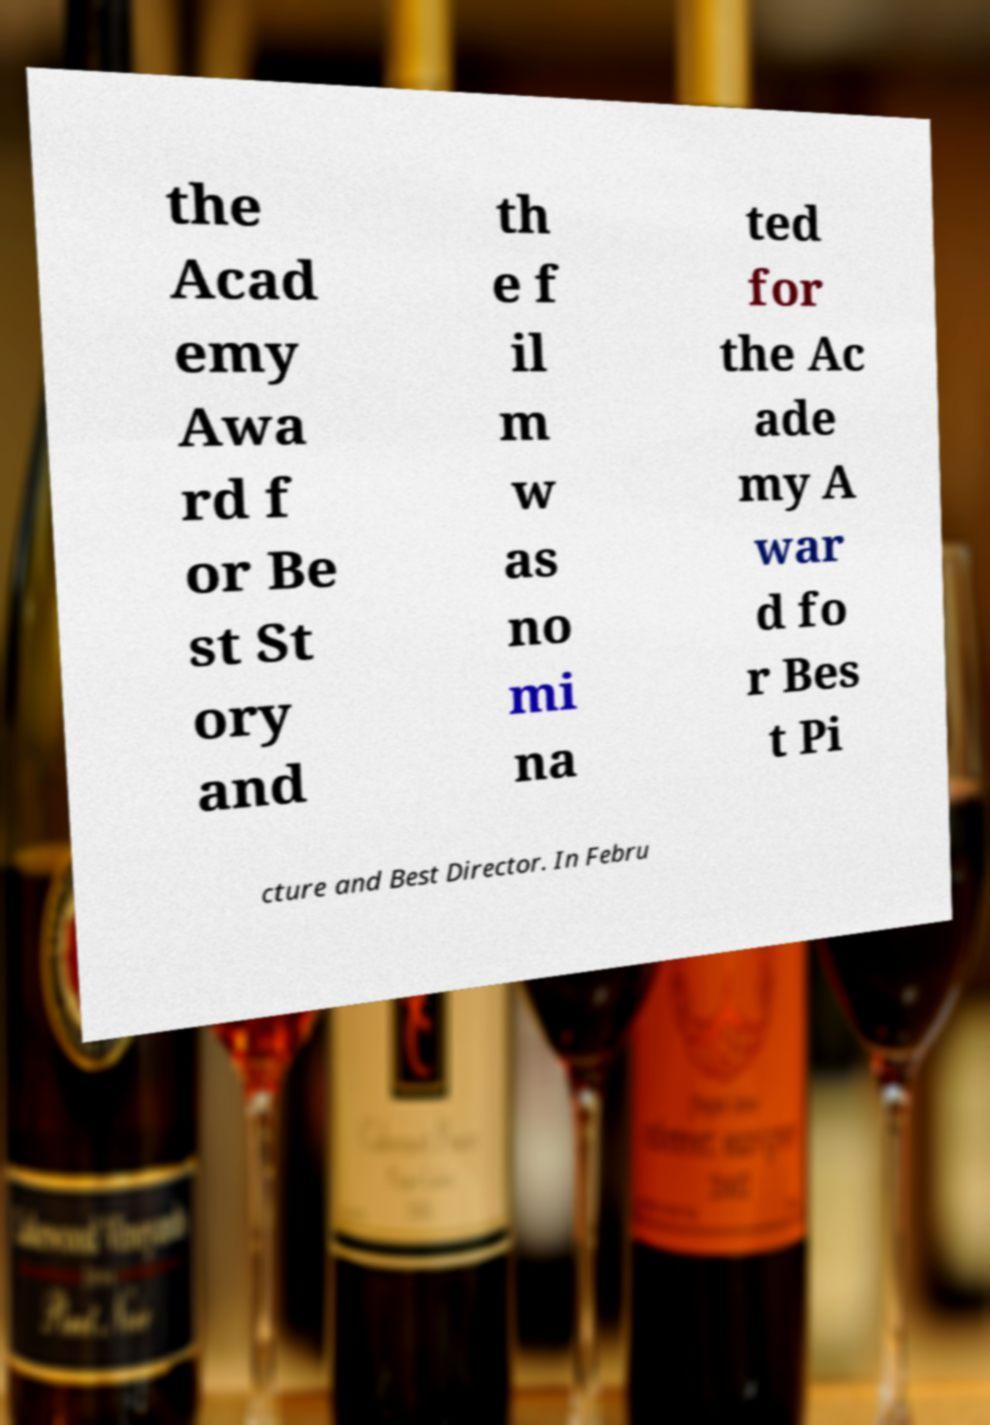Can you read and provide the text displayed in the image?This photo seems to have some interesting text. Can you extract and type it out for me? the Acad emy Awa rd f or Be st St ory and th e f il m w as no mi na ted for the Ac ade my A war d fo r Bes t Pi cture and Best Director. In Febru 